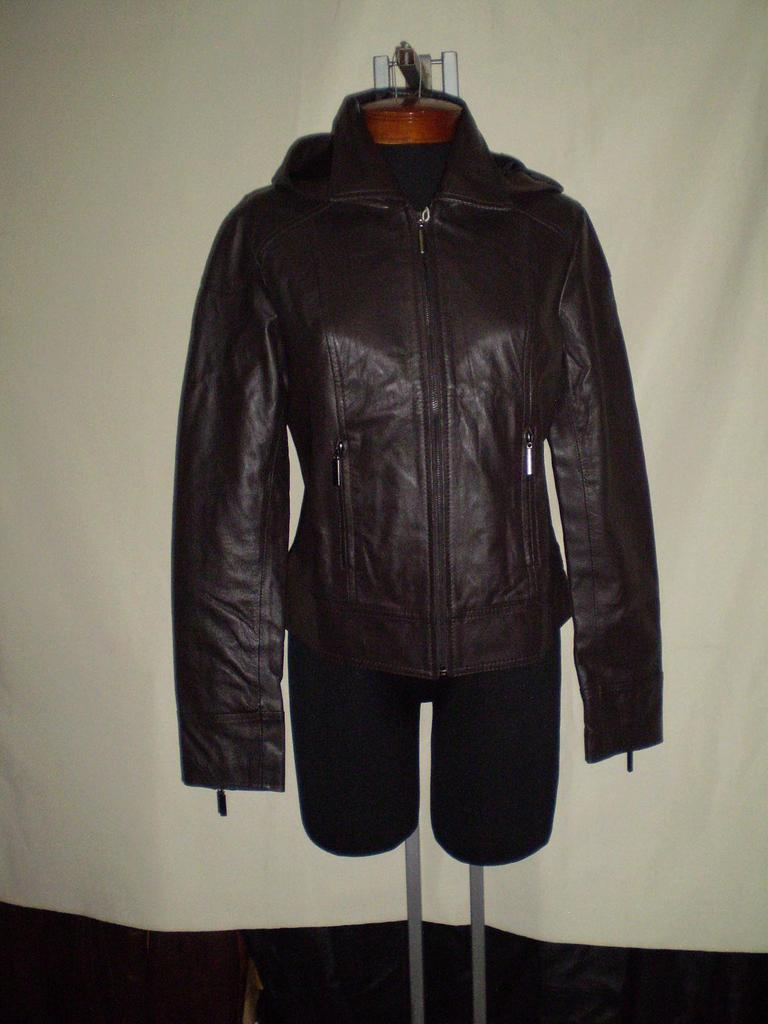What is located in the center of the image? There is a jacket and a bermuda in the center of the image. What color is the curtain in the background of the image? The curtain in the background of the image is white. What position does the wrench hold in the image? There is no wrench present in the image. What type of attraction can be seen in the background of the image? There is no attraction visible in the image; it only features a jacket, a bermuda, and a white curtain in the background. 